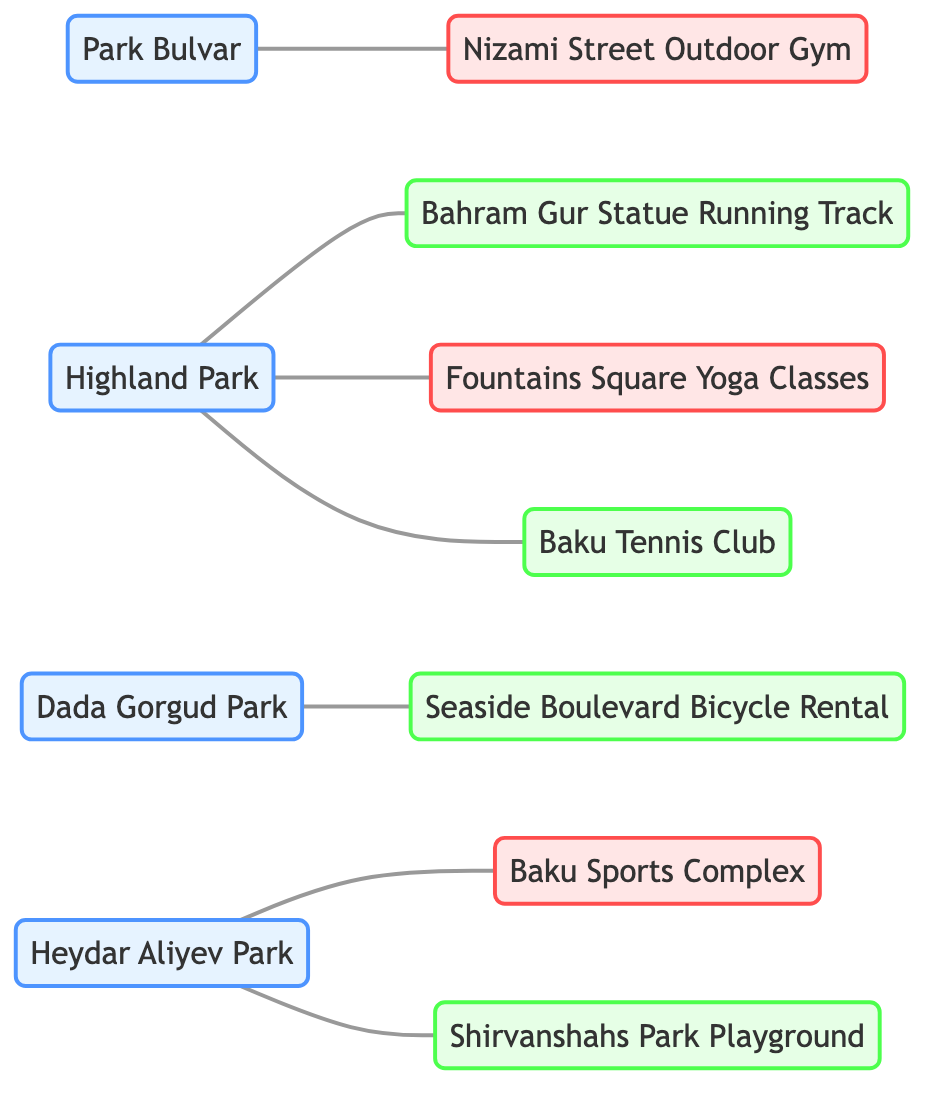What parks have fitness amenities? The nodes labeled as parks that have connections to fitness amenities are Highland Park and Heydar Aliyev Park. Highland Park is connected to Fountains Square Yoga Classes and Nizami Street Outdoor Gym is connected to Park Bulvar. The diagram directly shows these relationships.
Answer: Highland Park, Heydar Aliyev Park How many recreational amenities are mentioned in the diagram? By counting the nodes with the type "Recreational": Bahram Gur Statue Running Track, Seaside Boulevard Bicycle Rental, Baku Tennis Club, and Shirvanshahs Park Playground, we find there are four such amenities listed.
Answer: 4 Which park is nearby to both Bahram Gur Statue Running Track and Fountains Square Yoga Classes? Highland Park is connected to both Bahram Gur Statue Running Track and Fountains Square Yoga Classes. This is explicitly shown in the edges connecting the park to those amenities.
Answer: Highland Park What type of amenity is associated with Dada Gorgud Park? Dada Gorgud Park has a connection to Seaside Boulevard Bicycle Rental, which is categorized as a recreational amenity. This relationship can be seen as an edge in the diagram linking Dada Gorgud Park to the bicycle rental.
Answer: Recreational Which parks have playgrounds? The only park mentioned with an associated playground is Heydar Aliyev Park, which has a direct connection to Shirvanshahs Park Playground according to the diagram's edges.
Answer: Heydar Aliyev Park How many total nodes exist in the diagram? The total number of nodes, including both parks and amenities, is counted by listing them. There are 11 nodes in total: 4 parks and 7 amenities.
Answer: 11 Which park has both recreational and fitness amenities? Highland Park is the park that connects to both Fountains Square Yoga Classes (fitness) and Bahram Gur Statue Running Track (recreational), showing its diverse offerings depicted in the diagram.
Answer: Highland Park 